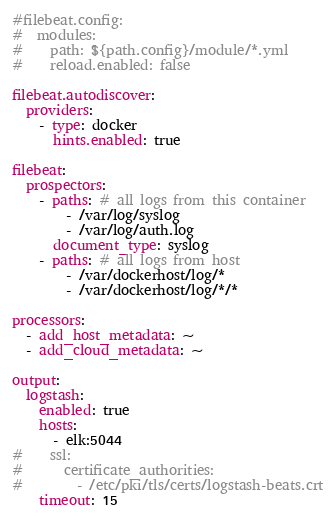<code> <loc_0><loc_0><loc_500><loc_500><_YAML_>#filebeat.config:
#  modules:
#    path: ${path.config}/module/*.yml
#    reload.enabled: false

filebeat.autodiscover:
  providers:
    - type: docker
      hints.enabled: true

filebeat:
  prospectors:
    - paths: # all logs from this container
        - /var/log/syslog
        - /var/log/auth.log
      document_type: syslog
    - paths: # all logs from host
        - /var/dockerhost/log/*
        - /var/dockerhost/log/*/*

processors:
  - add_host_metadata: ~
  - add_cloud_metadata: ~

output:
  logstash:
    enabled: true
    hosts:
      - elk:5044
#    ssl:
#      certificate_authorities:
#        - /etc/pki/tls/certs/logstash-beats.crt
    timeout: 15
</code> 